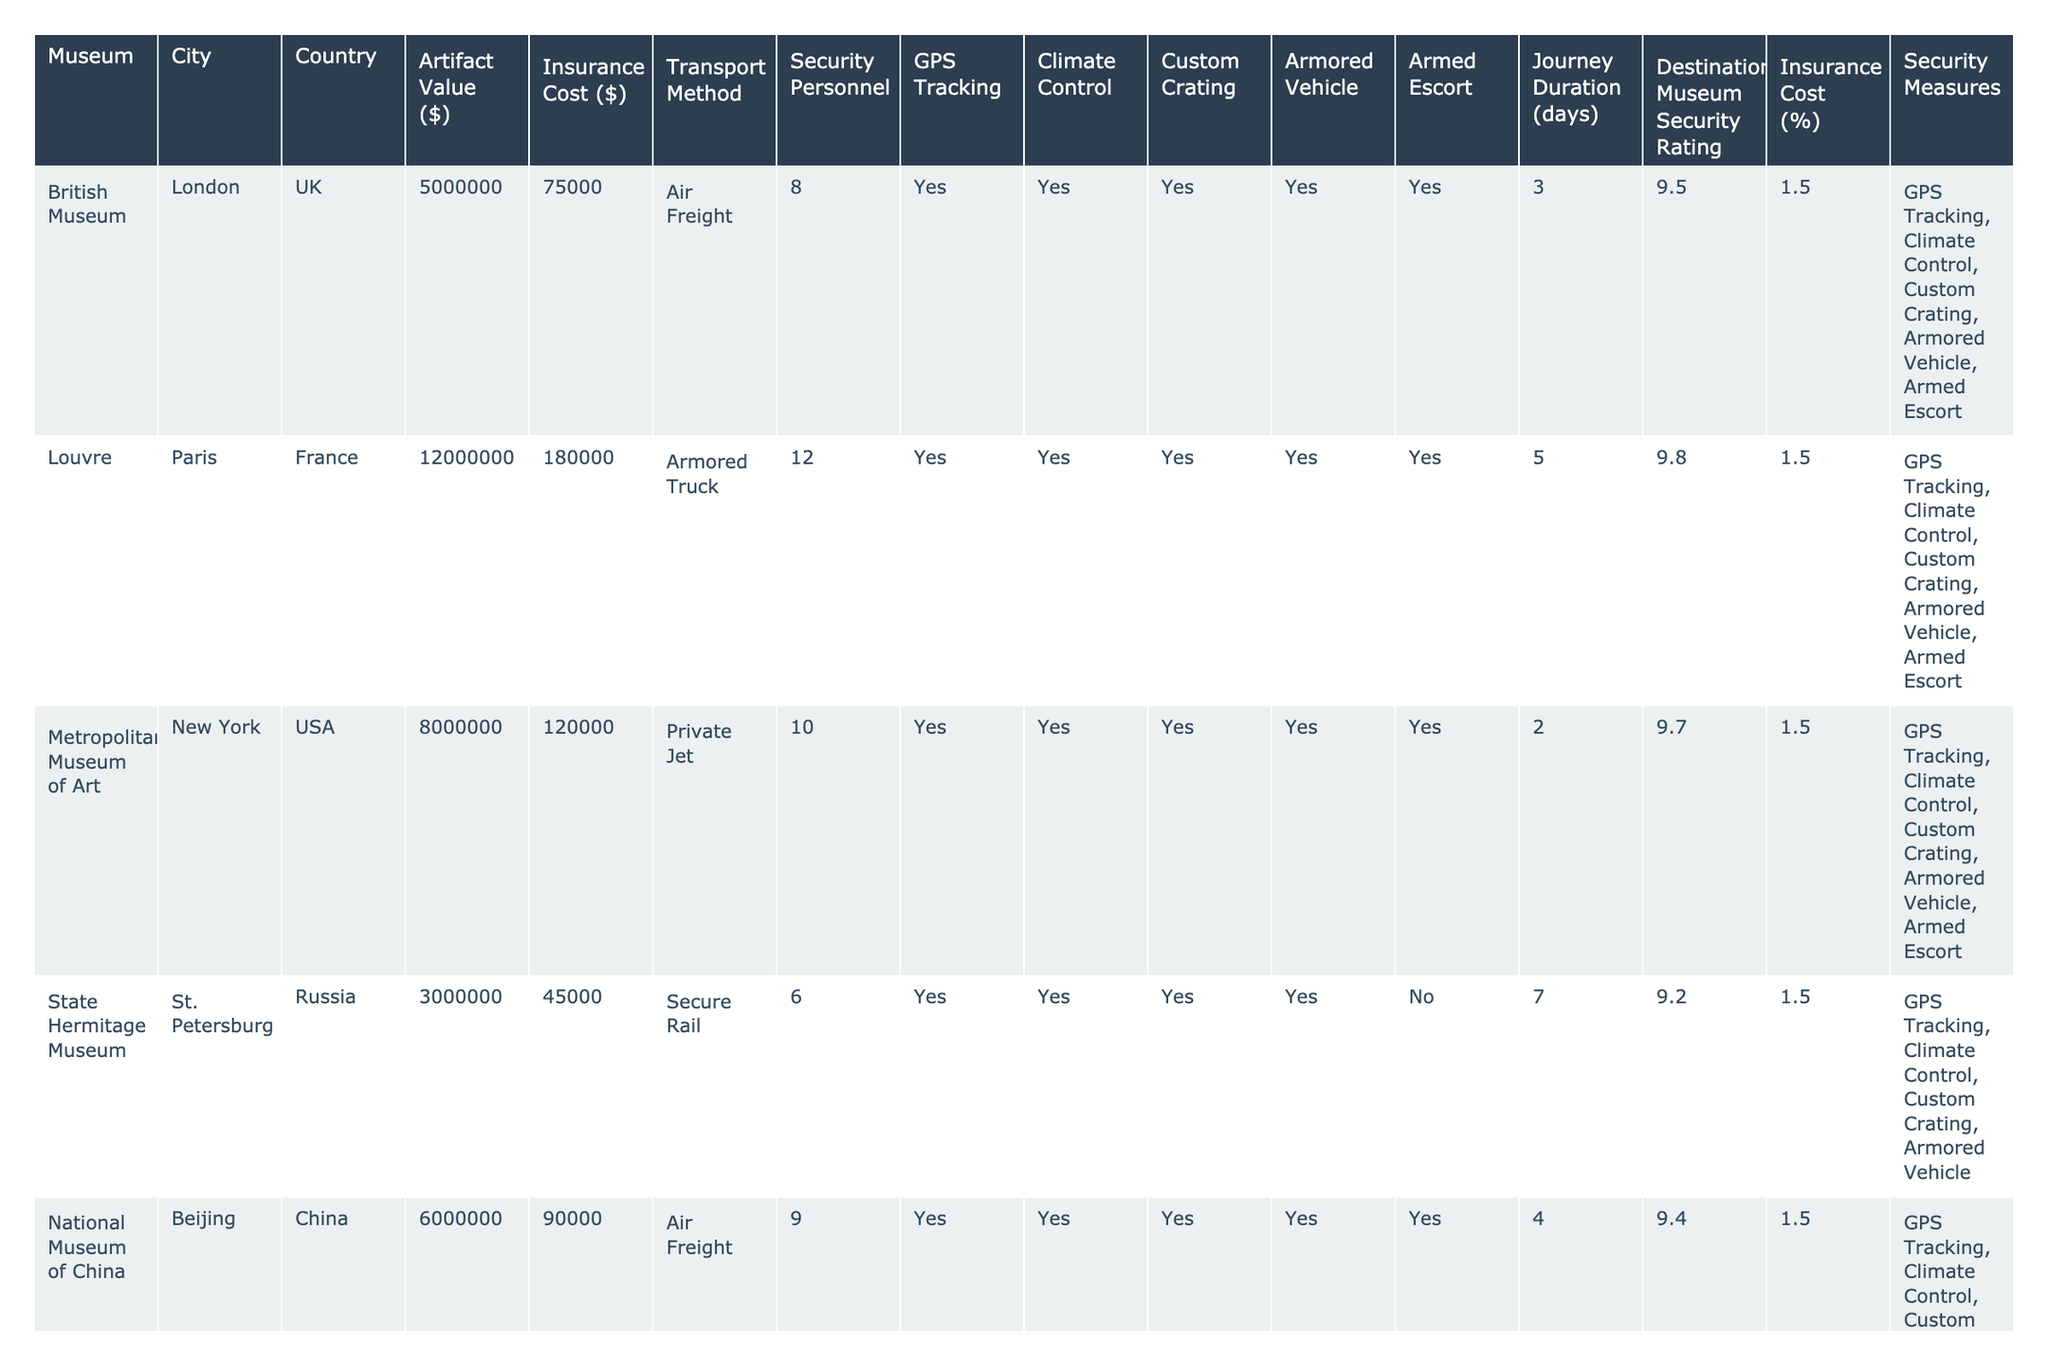What is the artifact value of the Louvre? The table shows that the artifact value for the Louvre is $12,000,000.
Answer: $12,000,000 How much is the insurance cost for the British Museum? According to the table, the insurance cost for the British Museum is $75,000.
Answer: $75,000 Which museum has the highest security personnel? The Vatican Museums have the highest security personnel at 15.
Answer: 15 Is GPS tracking used for artifacts transported to the Egyptian Museum? The table indicates that GPS tracking is listed as "Yes" for the Egyptian Museum.
Answer: Yes What is the average insurance cost for the museums listed? The total insurance cost of all museums is $1,057,500, with 15 museums listed. The average is $1,057,500 / 15 = $70,500.
Answer: $70,500 Which transport method is used by the National Museum of Anthropology? The transport method listed for the National Museum of Anthropology is Air Freight.
Answer: Air Freight How many museums use armored vehicles for transportation? The table shows that 10 out of 15 museums use armored vehicles, as indicated by a "Yes" in the corresponding column.
Answer: 10 What is the total artifact value of museums using private jets? The Metropolitan Museum of Art, Acropolis Museum, and Prado Museum use private jets with artifact values of $8,000,000, $5,500,000, and $9,000,000 respectively. Total value is $22,500,000.
Answer: $22,500,000 Is there any museum that has an armed escort but does not use an armored vehicle? The National Museum of Anthropology is the only museum that has an armed escort but no armored vehicle.
Answer: Yes What is the journey duration for the artifact transported to the Vatican Museums? The journey duration for the artifact to the Vatican Museums is 1 day according to the table.
Answer: 1 day Which country has the museum with the lowest insurance cost relative to artifact value? The Egyptian Museum has the lowest insurance cost of $30,000, which is 1.5% of its artifact value ($2,000,000).
Answer: Egypt 